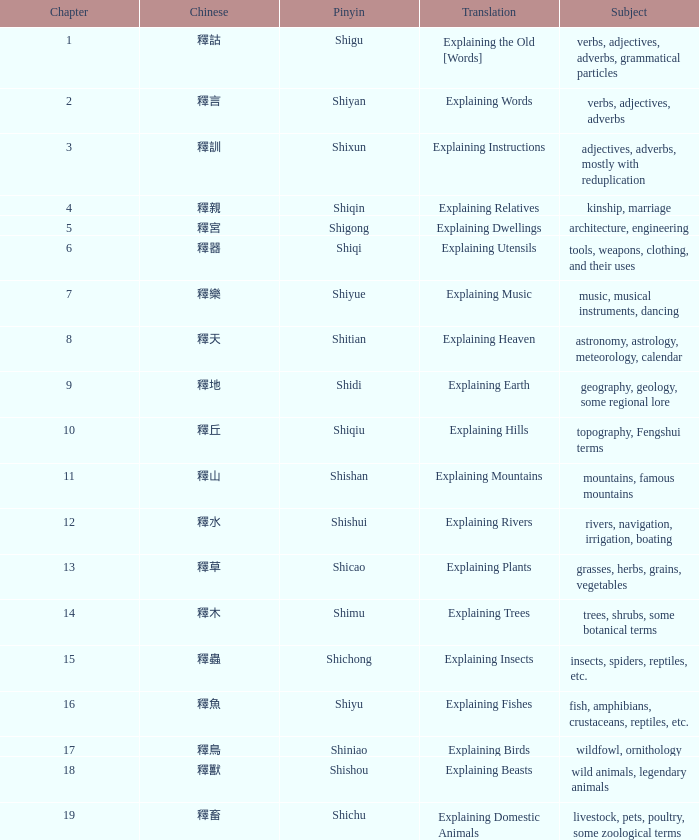Identify the complete quantity of chapters for the chinese 釋宮. 1.0. Would you be able to parse every entry in this table? {'header': ['Chapter', 'Chinese', 'Pinyin', 'Translation', 'Subject'], 'rows': [['1', '釋詁', 'Shigu', 'Explaining the Old [Words]', 'verbs, adjectives, adverbs, grammatical particles'], ['2', '釋言', 'Shiyan', 'Explaining Words', 'verbs, adjectives, adverbs'], ['3', '釋訓', 'Shixun', 'Explaining Instructions', 'adjectives, adverbs, mostly with reduplication'], ['4', '釋親', 'Shiqin', 'Explaining Relatives', 'kinship, marriage'], ['5', '釋宮', 'Shigong', 'Explaining Dwellings', 'architecture, engineering'], ['6', '釋器', 'Shiqi', 'Explaining Utensils', 'tools, weapons, clothing, and their uses'], ['7', '釋樂', 'Shiyue', 'Explaining Music', 'music, musical instruments, dancing'], ['8', '釋天', 'Shitian', 'Explaining Heaven', 'astronomy, astrology, meteorology, calendar'], ['9', '釋地', 'Shidi', 'Explaining Earth', 'geography, geology, some regional lore'], ['10', '釋丘', 'Shiqiu', 'Explaining Hills', 'topography, Fengshui terms'], ['11', '釋山', 'Shishan', 'Explaining Mountains', 'mountains, famous mountains'], ['12', '釋水', 'Shishui', 'Explaining Rivers', 'rivers, navigation, irrigation, boating'], ['13', '釋草', 'Shicao', 'Explaining Plants', 'grasses, herbs, grains, vegetables'], ['14', '釋木', 'Shimu', 'Explaining Trees', 'trees, shrubs, some botanical terms'], ['15', '釋蟲', 'Shichong', 'Explaining Insects', 'insects, spiders, reptiles, etc.'], ['16', '釋魚', 'Shiyu', 'Explaining Fishes', 'fish, amphibians, crustaceans, reptiles, etc.'], ['17', '釋鳥', 'Shiniao', 'Explaining Birds', 'wildfowl, ornithology'], ['18', '釋獸', 'Shishou', 'Explaining Beasts', 'wild animals, legendary animals'], ['19', '釋畜', 'Shichu', 'Explaining Domestic Animals', 'livestock, pets, poultry, some zoological terms']]} 